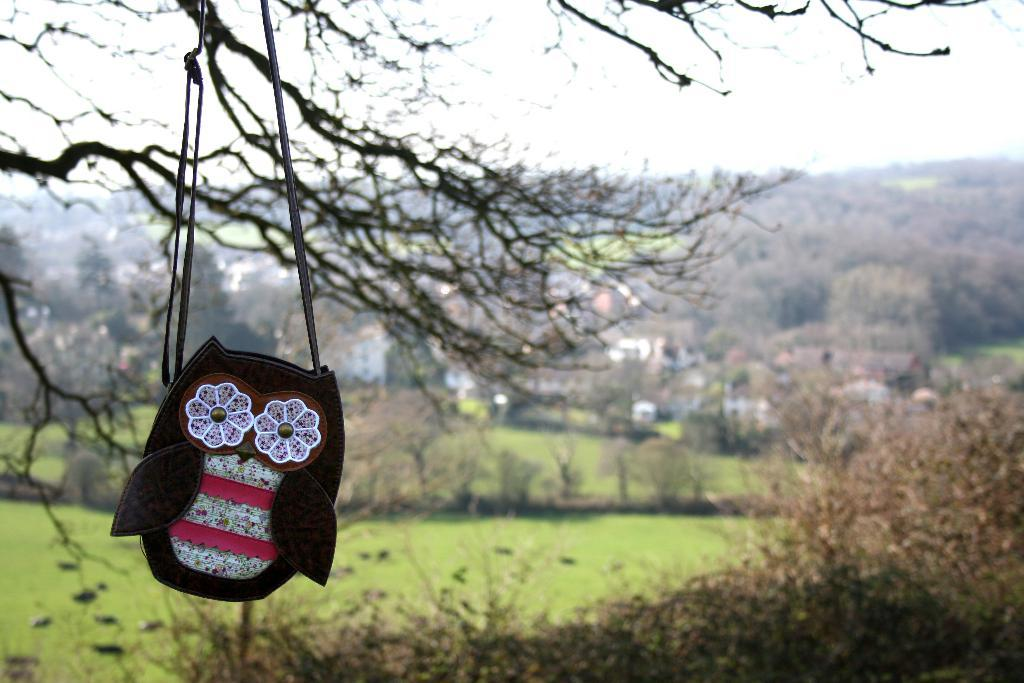What is hanging in the foreground of the image? There is a sling bag hanging in the foreground of the image. What type of natural vegetation visible in the image? There are trees and grassland in the image. What type of structures can be seen in the image? There are houses in the image. What is visible in the background of the image? It appears that there are mountains in the background, and the sky is visible. Can you hear the voice of the person who needs to attempt to climb the mountain in the image? There is no person or voice present in the image, and no one is attempting to climb the mountain. 